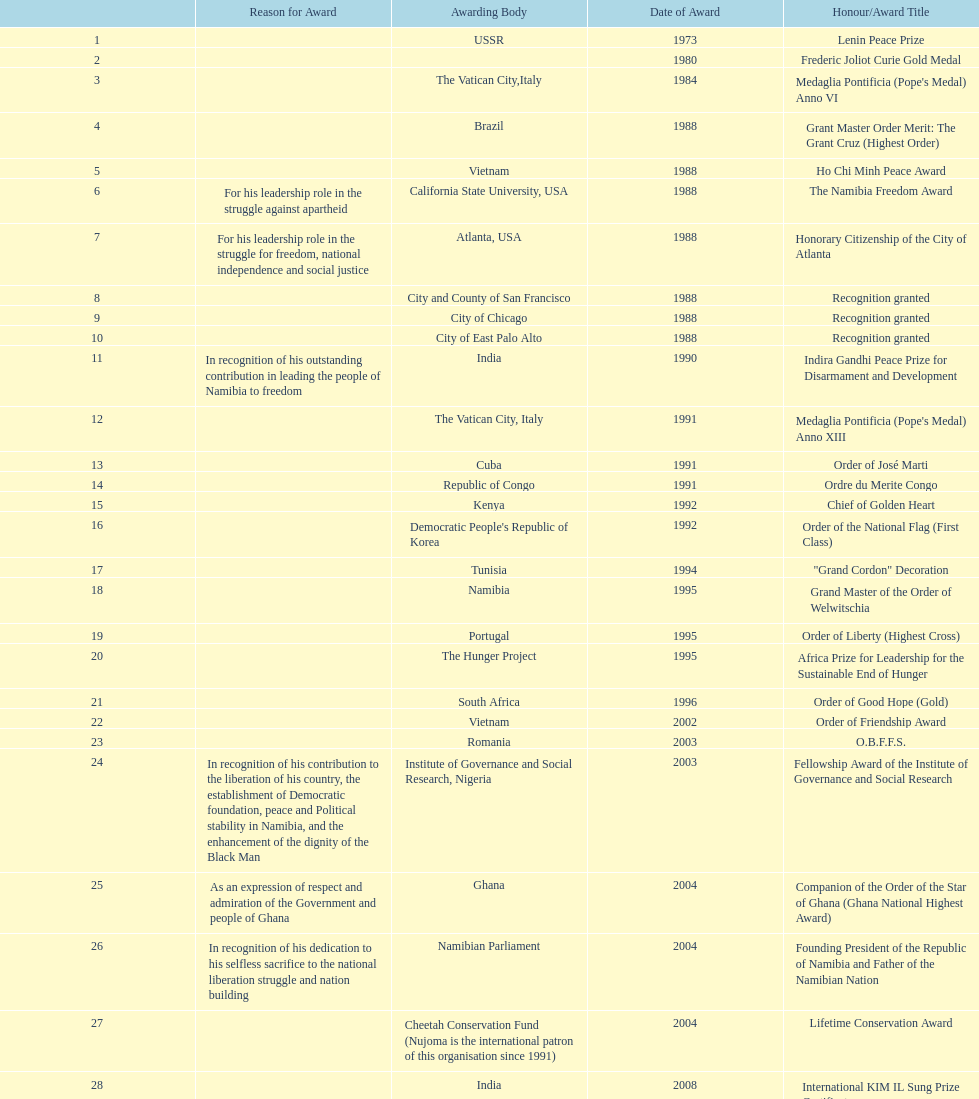Did nujoma win the o.b.f.f.s. award in romania or ghana? Romania. 